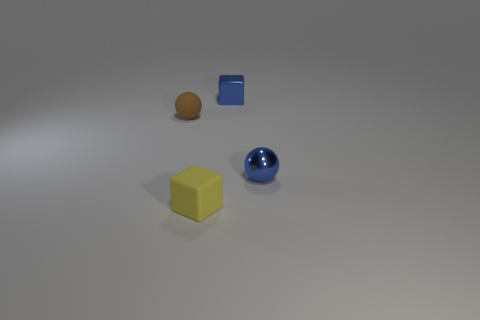Add 3 tiny yellow objects. How many objects exist? 7 Subtract all yellow objects. Subtract all brown matte balls. How many objects are left? 2 Add 2 balls. How many balls are left? 4 Add 2 big purple cylinders. How many big purple cylinders exist? 2 Subtract 0 green cylinders. How many objects are left? 4 